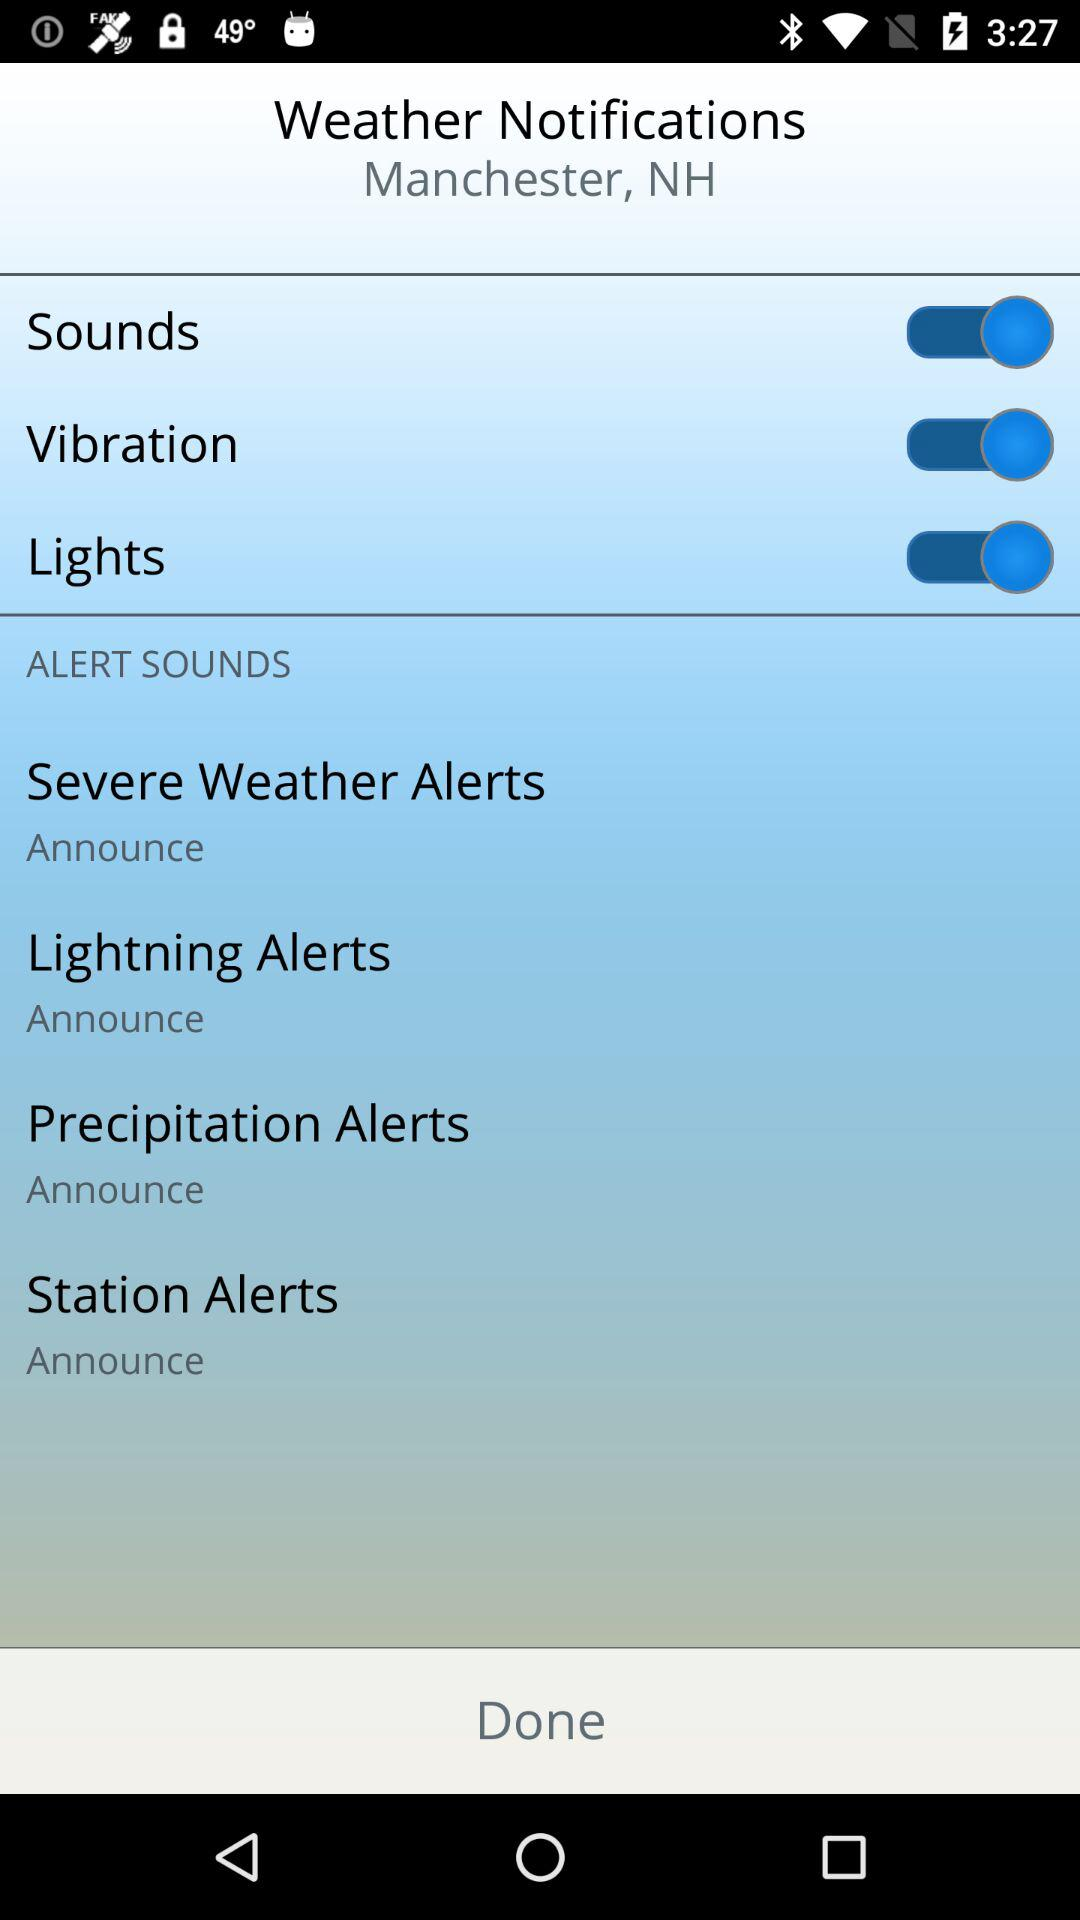How many alert sounds are there?
Answer the question using a single word or phrase. 4 